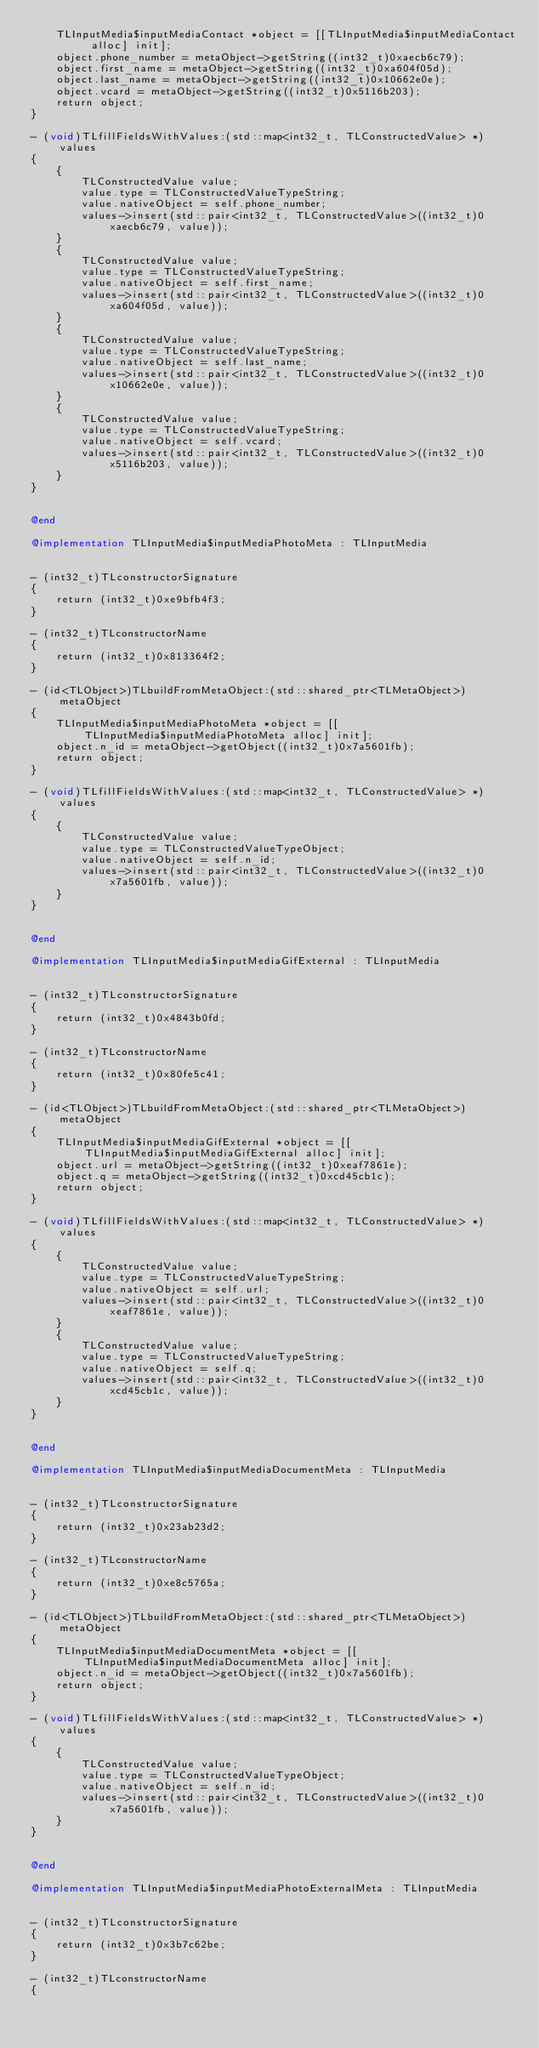<code> <loc_0><loc_0><loc_500><loc_500><_ObjectiveC_>    TLInputMedia$inputMediaContact *object = [[TLInputMedia$inputMediaContact alloc] init];
    object.phone_number = metaObject->getString((int32_t)0xaecb6c79);
    object.first_name = metaObject->getString((int32_t)0xa604f05d);
    object.last_name = metaObject->getString((int32_t)0x10662e0e);
    object.vcard = metaObject->getString((int32_t)0x5116b203);
    return object;
}

- (void)TLfillFieldsWithValues:(std::map<int32_t, TLConstructedValue> *)values
{
    {
        TLConstructedValue value;
        value.type = TLConstructedValueTypeString;
        value.nativeObject = self.phone_number;
        values->insert(std::pair<int32_t, TLConstructedValue>((int32_t)0xaecb6c79, value));
    }
    {
        TLConstructedValue value;
        value.type = TLConstructedValueTypeString;
        value.nativeObject = self.first_name;
        values->insert(std::pair<int32_t, TLConstructedValue>((int32_t)0xa604f05d, value));
    }
    {
        TLConstructedValue value;
        value.type = TLConstructedValueTypeString;
        value.nativeObject = self.last_name;
        values->insert(std::pair<int32_t, TLConstructedValue>((int32_t)0x10662e0e, value));
    }
    {
        TLConstructedValue value;
        value.type = TLConstructedValueTypeString;
        value.nativeObject = self.vcard;
        values->insert(std::pair<int32_t, TLConstructedValue>((int32_t)0x5116b203, value));
    }
}


@end

@implementation TLInputMedia$inputMediaPhotoMeta : TLInputMedia


- (int32_t)TLconstructorSignature
{
    return (int32_t)0xe9bfb4f3;
}

- (int32_t)TLconstructorName
{
    return (int32_t)0x813364f2;
}

- (id<TLObject>)TLbuildFromMetaObject:(std::shared_ptr<TLMetaObject>)metaObject
{
    TLInputMedia$inputMediaPhotoMeta *object = [[TLInputMedia$inputMediaPhotoMeta alloc] init];
    object.n_id = metaObject->getObject((int32_t)0x7a5601fb);
    return object;
}

- (void)TLfillFieldsWithValues:(std::map<int32_t, TLConstructedValue> *)values
{
    {
        TLConstructedValue value;
        value.type = TLConstructedValueTypeObject;
        value.nativeObject = self.n_id;
        values->insert(std::pair<int32_t, TLConstructedValue>((int32_t)0x7a5601fb, value));
    }
}


@end

@implementation TLInputMedia$inputMediaGifExternal : TLInputMedia


- (int32_t)TLconstructorSignature
{
    return (int32_t)0x4843b0fd;
}

- (int32_t)TLconstructorName
{
    return (int32_t)0x80fe5c41;
}

- (id<TLObject>)TLbuildFromMetaObject:(std::shared_ptr<TLMetaObject>)metaObject
{
    TLInputMedia$inputMediaGifExternal *object = [[TLInputMedia$inputMediaGifExternal alloc] init];
    object.url = metaObject->getString((int32_t)0xeaf7861e);
    object.q = metaObject->getString((int32_t)0xcd45cb1c);
    return object;
}

- (void)TLfillFieldsWithValues:(std::map<int32_t, TLConstructedValue> *)values
{
    {
        TLConstructedValue value;
        value.type = TLConstructedValueTypeString;
        value.nativeObject = self.url;
        values->insert(std::pair<int32_t, TLConstructedValue>((int32_t)0xeaf7861e, value));
    }
    {
        TLConstructedValue value;
        value.type = TLConstructedValueTypeString;
        value.nativeObject = self.q;
        values->insert(std::pair<int32_t, TLConstructedValue>((int32_t)0xcd45cb1c, value));
    }
}


@end

@implementation TLInputMedia$inputMediaDocumentMeta : TLInputMedia


- (int32_t)TLconstructorSignature
{
    return (int32_t)0x23ab23d2;
}

- (int32_t)TLconstructorName
{
    return (int32_t)0xe8c5765a;
}

- (id<TLObject>)TLbuildFromMetaObject:(std::shared_ptr<TLMetaObject>)metaObject
{
    TLInputMedia$inputMediaDocumentMeta *object = [[TLInputMedia$inputMediaDocumentMeta alloc] init];
    object.n_id = metaObject->getObject((int32_t)0x7a5601fb);
    return object;
}

- (void)TLfillFieldsWithValues:(std::map<int32_t, TLConstructedValue> *)values
{
    {
        TLConstructedValue value;
        value.type = TLConstructedValueTypeObject;
        value.nativeObject = self.n_id;
        values->insert(std::pair<int32_t, TLConstructedValue>((int32_t)0x7a5601fb, value));
    }
}


@end

@implementation TLInputMedia$inputMediaPhotoExternalMeta : TLInputMedia


- (int32_t)TLconstructorSignature
{
    return (int32_t)0x3b7c62be;
}

- (int32_t)TLconstructorName
{</code> 